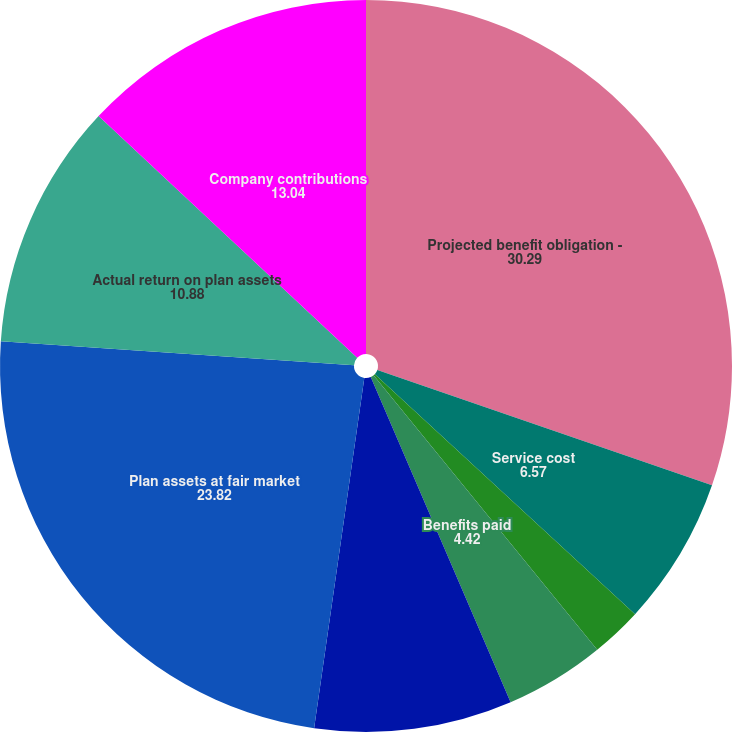<chart> <loc_0><loc_0><loc_500><loc_500><pie_chart><fcel>Projected benefit obligation -<fcel>Service cost<fcel>Interest cost<fcel>Benefits paid<fcel>Actuarial (gain) loss<fcel>Plan assets at fair market<fcel>Actual return on plan assets<fcel>Company contributions<nl><fcel>30.29%<fcel>6.57%<fcel>2.26%<fcel>4.42%<fcel>8.73%<fcel>23.82%<fcel>10.88%<fcel>13.04%<nl></chart> 